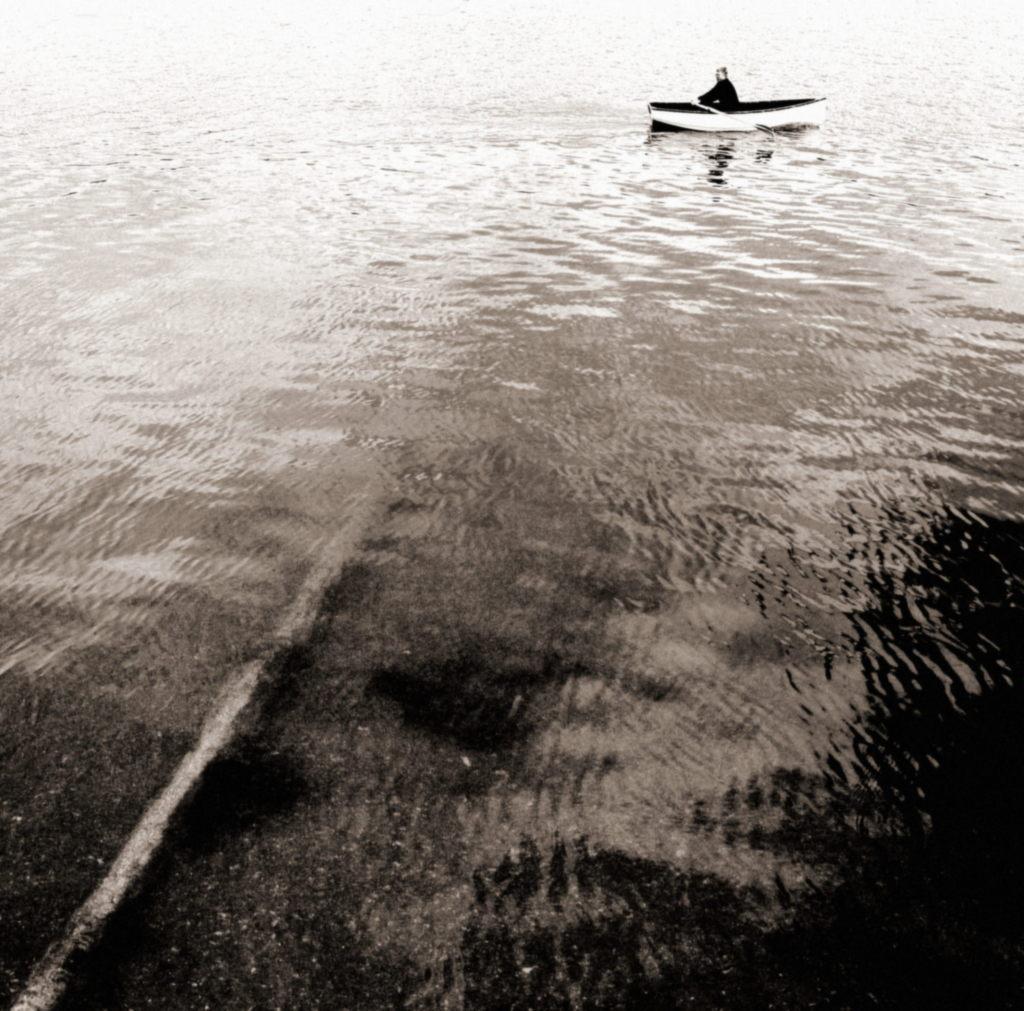How would you summarize this image in a sentence or two? In this image there is water and we can see a boat on the water. There is a person sitting in the boat. 